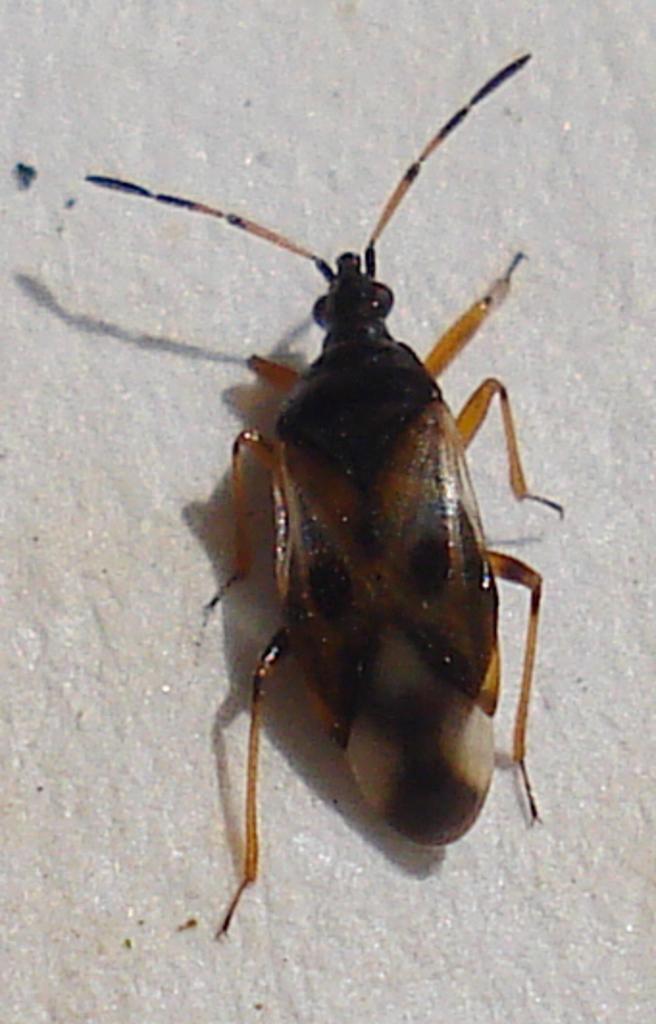How would you summarize this image in a sentence or two? In this picture we can see an insect on a surface. 